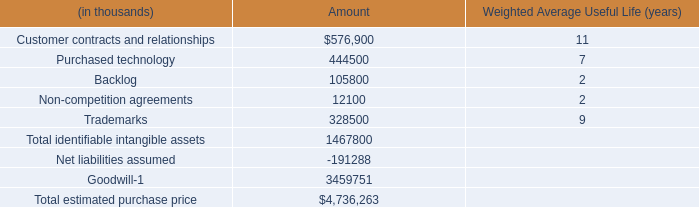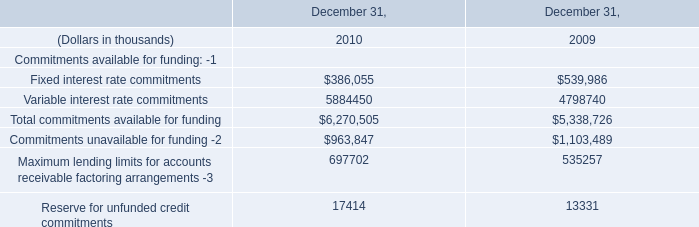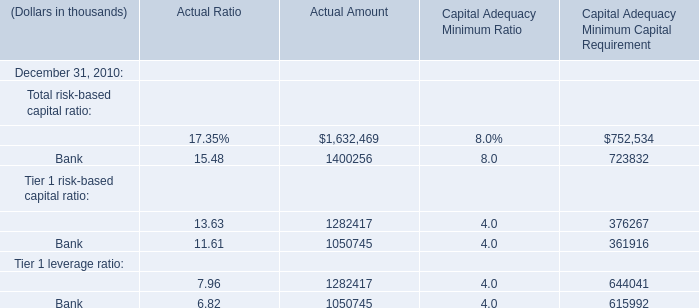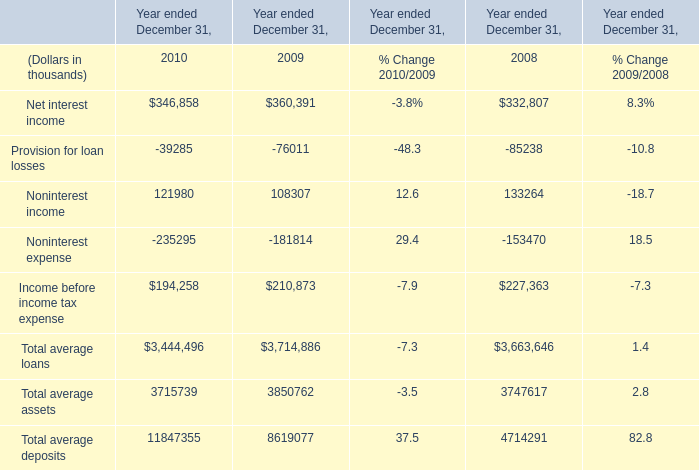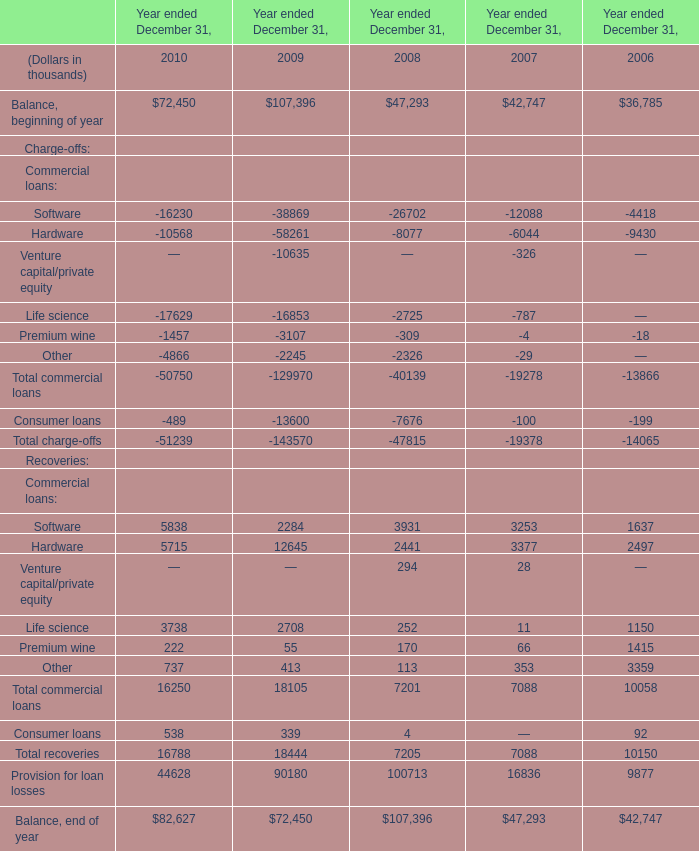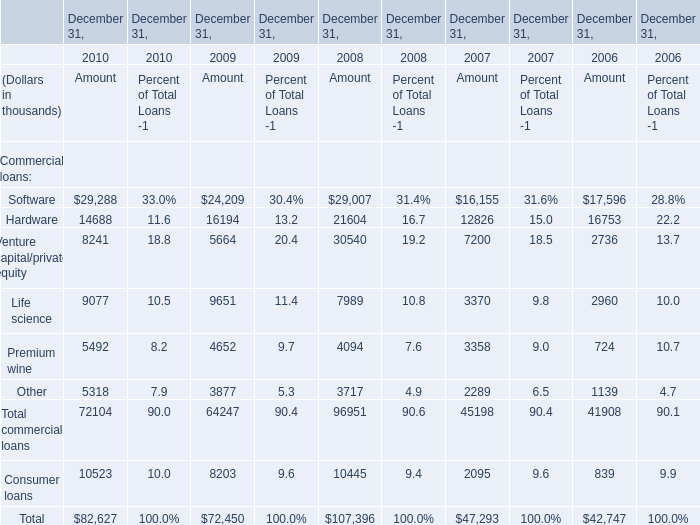What is the average value of Software for Recoveries in 2009,2008 and 2007? (in thousand) 
Computations: (((2284 + 3931) + 3253) / 3)
Answer: 3156.0. 